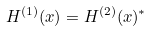<formula> <loc_0><loc_0><loc_500><loc_500>H ^ { ( 1 ) } ( x ) = H ^ { ( 2 ) } ( x ) ^ { * }</formula> 